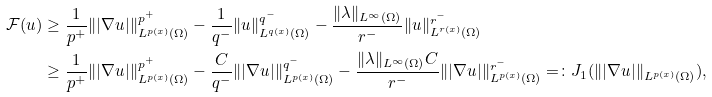Convert formula to latex. <formula><loc_0><loc_0><loc_500><loc_500>\mathcal { F } ( u ) & \geq \frac { 1 } { p ^ { + } } \| | \nabla u | \| ^ { p ^ { + } } _ { L ^ { p ( x ) } ( \Omega ) } - \frac { 1 } { q ^ { - } } \| u \| ^ { q ^ { - } } _ { L ^ { q ( x ) } ( \Omega ) } - \frac { \| \lambda \| _ { L ^ { \infty } ( \Omega ) } } { r ^ { - } } \| u \| _ { L ^ { r ( x ) } ( \Omega ) } ^ { r ^ { - } } \\ & \geq \frac { 1 } { p ^ { + } } \| | \nabla u | \| ^ { p ^ { + } } _ { L ^ { p ( x ) } ( \Omega ) } - \frac { C } { q ^ { - } } \| | \nabla u | \| ^ { q ^ { - } } _ { L ^ { p ( x ) } ( \Omega ) } - \frac { \| \lambda \| _ { L ^ { \infty } ( \Omega ) } C } { r ^ { - } } \| | \nabla u | \| _ { L ^ { p ( x ) } ( \Omega ) } ^ { r ^ { - } } = \colon J _ { 1 } ( \| | \nabla u | \| _ { L ^ { p ( x ) } ( \Omega ) } ) ,</formula> 